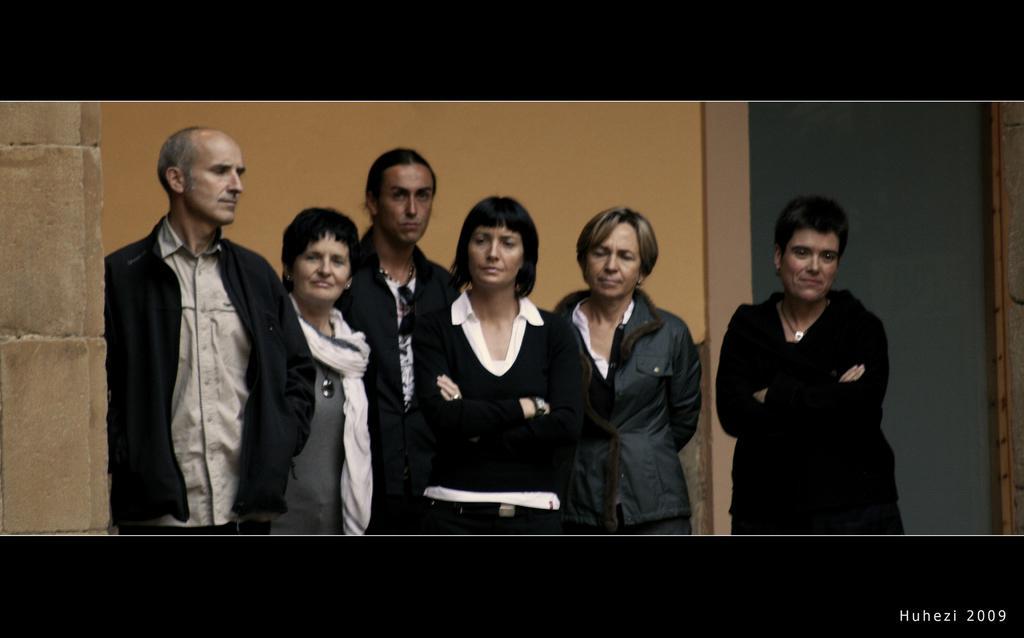How would you summarize this image in a sentence or two? This is an edited image. In this image we can see some persons. In the background of the image there is a wall and an object. On the left side of the image there is a wall. At the top and bottom of the image there is a dark view. On the image there is a watermark. 